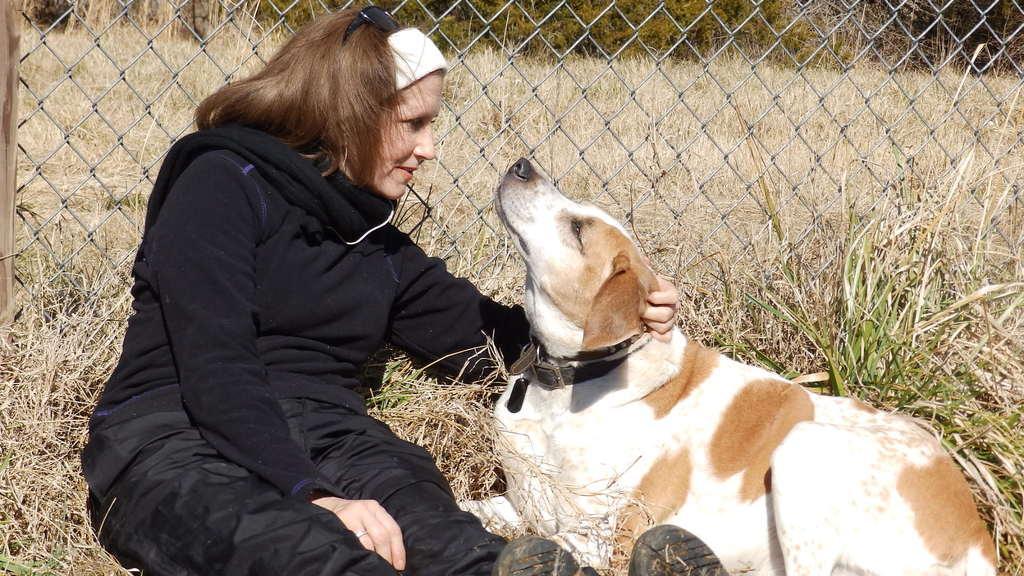Could you give a brief overview of what you see in this image? In this picture, we can see a person with a dog sitting on the ground and the ground is covered with dry grass and we can see the net, plants, trees. 